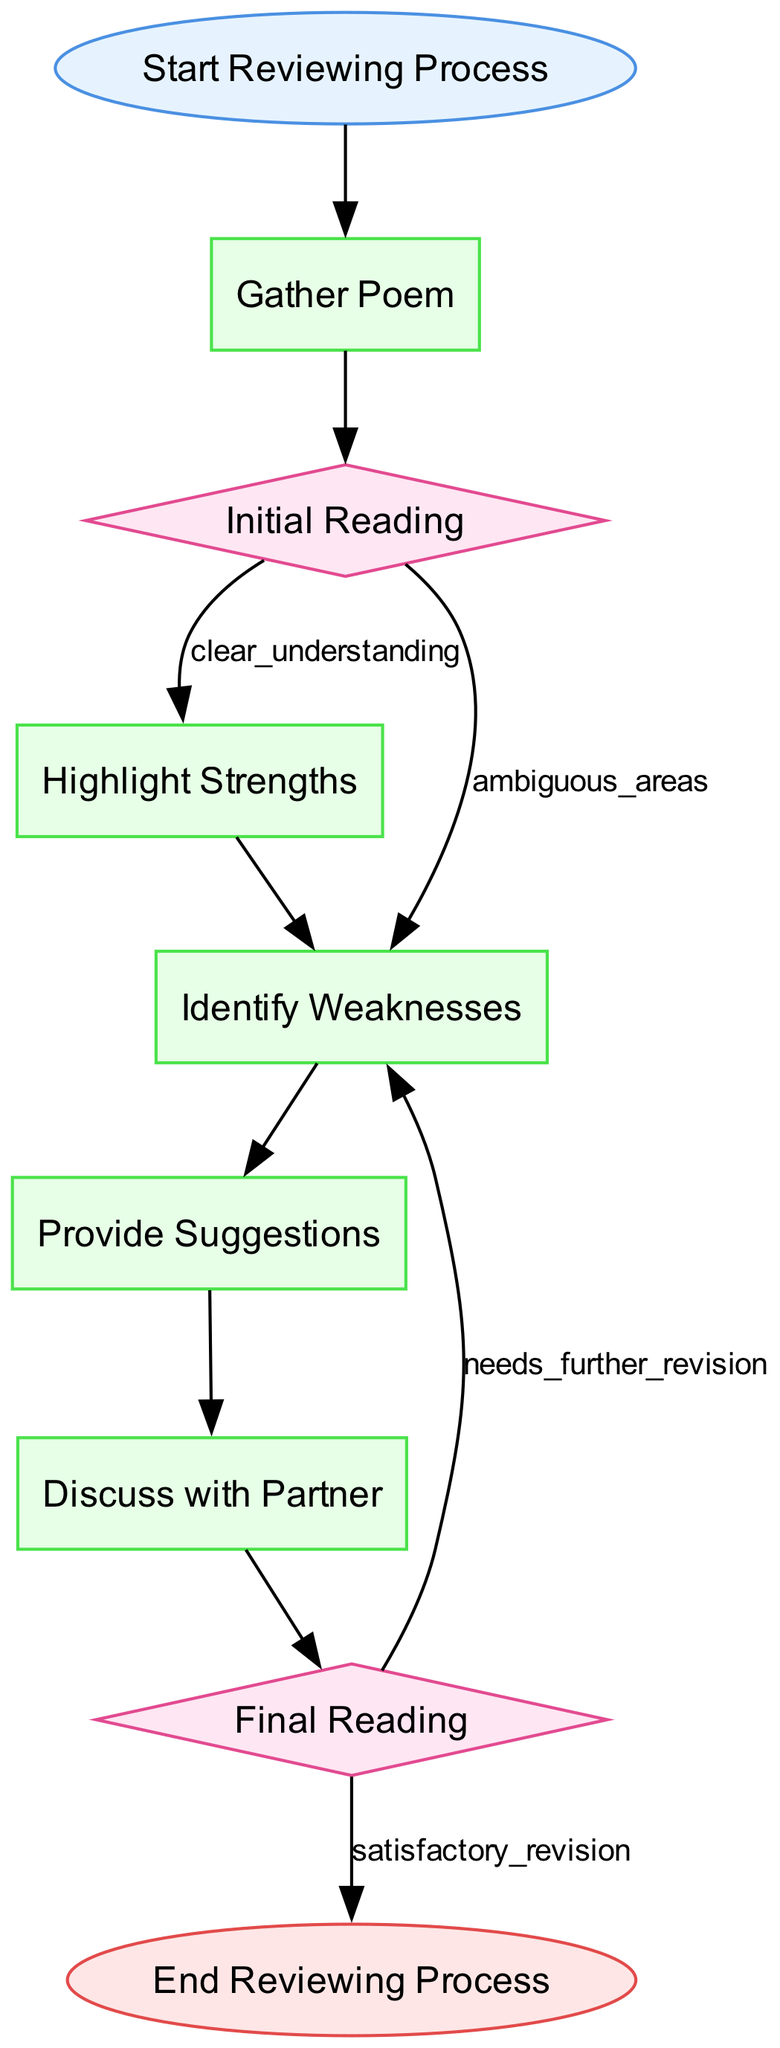What is the first step in the reviewing process? The first step is represented by the "Start Reviewing Process" node, which leads to the next step of "Gather Poem."
Answer: Gather Poem How many types of nodes are in the diagram? There are three types of nodes in the diagram: Start, Process, Decision. Counting them gives us a total of three different types.
Answer: Three What follows after identifying weaknesses? After identifying weaknesses, the flowchart indicates that the next step is to provide suggestions for revisions.
Answer: Provide Suggestions What happens if the final reading indicates further revisions are required? If further revisions are needed, the flow proceeds back to the "Identify Weaknesses" process, indicating that additional improvements must be addressed.
Answer: Identify Weaknesses What does the node "Highlight Strengths" suggest about the process? This node indicates that after an initial reading, the reviewer should note the strong poetic elements, which means it focuses on the positive aspects of the poem.
Answer: Identify strong poetic elements How many edges lead out from the "Final Reading" decision node? The "Final Reading" node has two edges leading out: one for satisfactory revisions and the other for needing further revisions.
Answer: Two What is the purpose of the "Discuss with Partner" step? The purpose of "Discuss with Partner" is to facilitate a conversation about the feedback provided and collaboratively work on revisions, emphasizing the importance of collaboration.
Answer: Collaboration on revisions What does the flowchart ultimately lead to after satisfactory revisions? After revisions are deemed satisfactory, the flowchart leads to the end of the reviewing process, indicating the conclusion of the feedback loop.
Answer: End Reviewing Process 